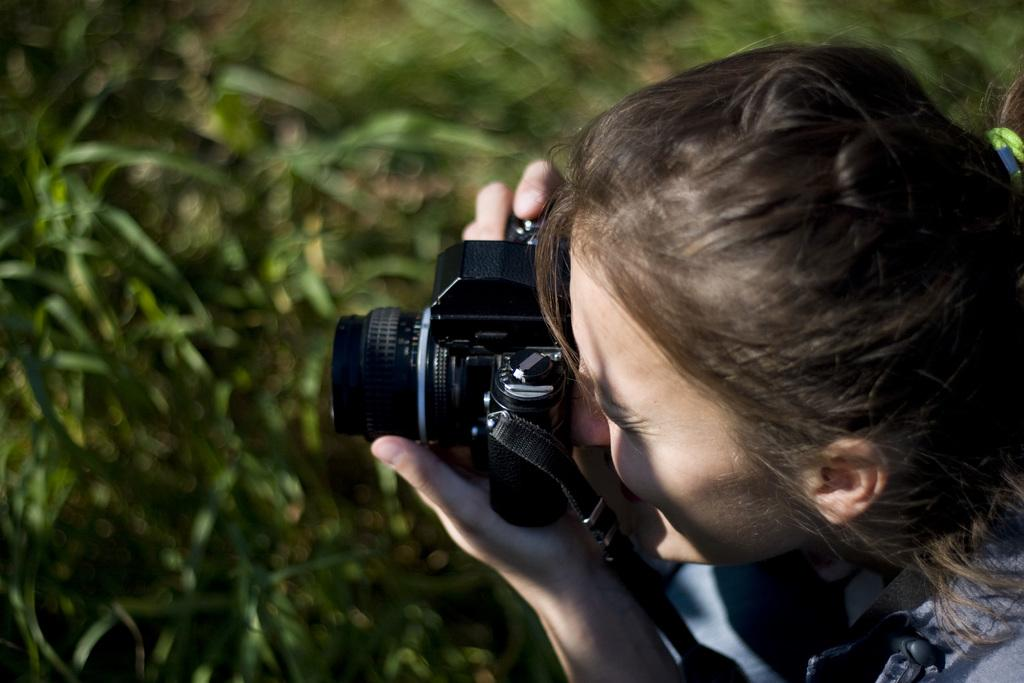Who is the main subject in the image? There is a woman in the image. What is the woman doing in the image? The woman is holding a camera with her hand and taking a picture. What can be seen in the background of the image? There are trees in the background of the image. How is the background depicted in the image? The background appears blurry. What type of yam is being used as a prop in the image? There is no yam present in the image. Is the woman being attacked by any animals in the image? There are no animals present in the image, and the woman is not being attacked. 